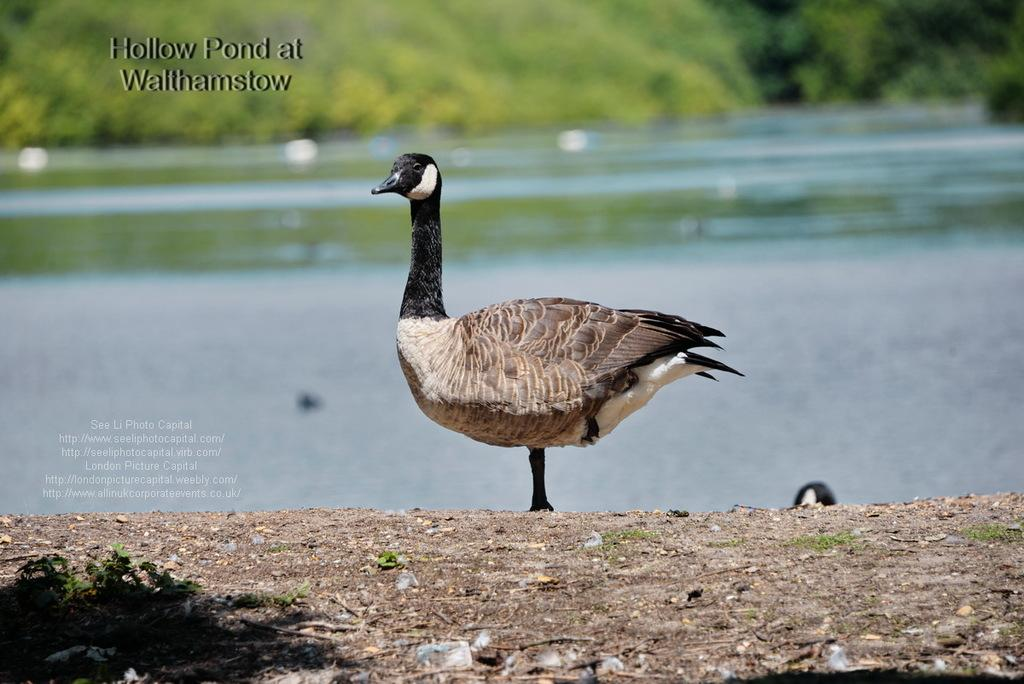What animal is present in the image? There is a duck in the image. What is the duck's position in the image? The duck is standing on the ground. What can be seen in the background of the image? There is water visible in the image. What type of visual representation is the image? The image is a poster. What shape is the spoon in the image? There is no spoon present in the image. 